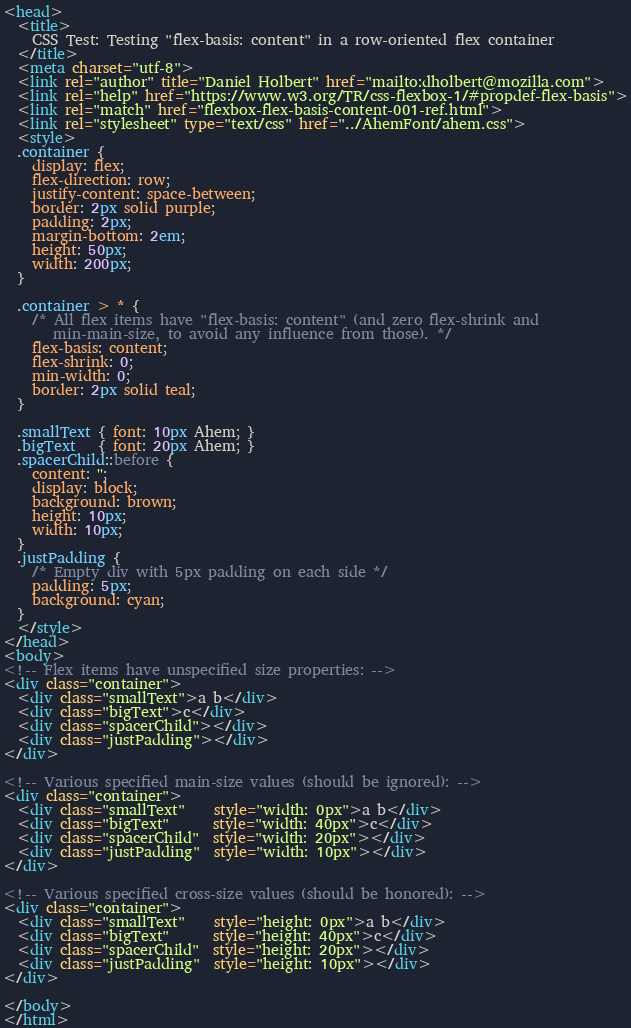Convert code to text. <code><loc_0><loc_0><loc_500><loc_500><_HTML_><head>
  <title>
    CSS Test: Testing "flex-basis: content" in a row-oriented flex container
  </title>
  <meta charset="utf-8">
  <link rel="author" title="Daniel Holbert" href="mailto:dholbert@mozilla.com">
  <link rel="help" href="https://www.w3.org/TR/css-flexbox-1/#propdef-flex-basis">
  <link rel="match" href="flexbox-flex-basis-content-001-ref.html">
  <link rel="stylesheet" type="text/css" href="../AhemFont/ahem.css">
  <style>
  .container {
    display: flex;
    flex-direction: row;
    justify-content: space-between;
    border: 2px solid purple;
    padding: 2px;
    margin-bottom: 2em;
    height: 50px;
    width: 200px;
  }

  .container > * {
    /* All flex items have "flex-basis: content" (and zero flex-shrink and
       min-main-size, to avoid any influence from those). */
    flex-basis: content;
    flex-shrink: 0;
    min-width: 0;
    border: 2px solid teal;
  }

  .smallText { font: 10px Ahem; }
  .bigText   { font: 20px Ahem; }
  .spacerChild::before {
    content: '';
    display: block;
    background: brown;
    height: 10px;
    width: 10px;
  }
  .justPadding {
    /* Empty div with 5px padding on each side */
    padding: 5px;
    background: cyan;
  }
  </style>
</head>
<body>
<!-- Flex items have unspecified size properties: -->
<div class="container">
  <div class="smallText">a b</div>
  <div class="bigText">c</div>
  <div class="spacerChild"></div>
  <div class="justPadding"></div>
</div>

<!-- Various specified main-size values (should be ignored): -->
<div class="container">
  <div class="smallText"    style="width: 0px">a b</div>
  <div class="bigText"      style="width: 40px">c</div>
  <div class="spacerChild"  style="width: 20px"></div>
  <div class="justPadding"  style="width: 10px"></div>
</div>

<!-- Various specified cross-size values (should be honored): -->
<div class="container">
  <div class="smallText"    style="height: 0px">a b</div>
  <div class="bigText"      style="height: 40px">c</div>
  <div class="spacerChild"  style="height: 20px"></div>
  <div class="justPadding"  style="height: 10px"></div>
</div>

</body>
</html>
</code> 